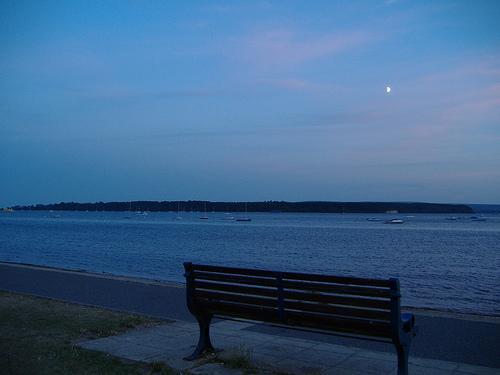How many people are sitting on the bench?
Give a very brief answer. 0. 